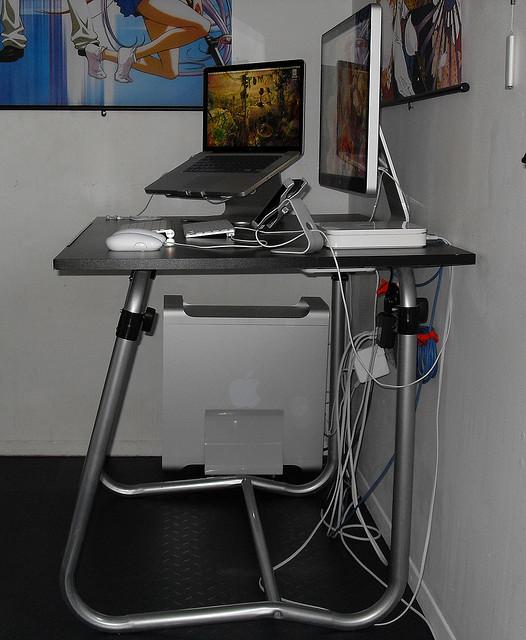Does this room belong to an elderly person?
Answer briefly. No. Does this room have carpet?
Short answer required. No. What is on the desk?
Concise answer only. Laptop. 